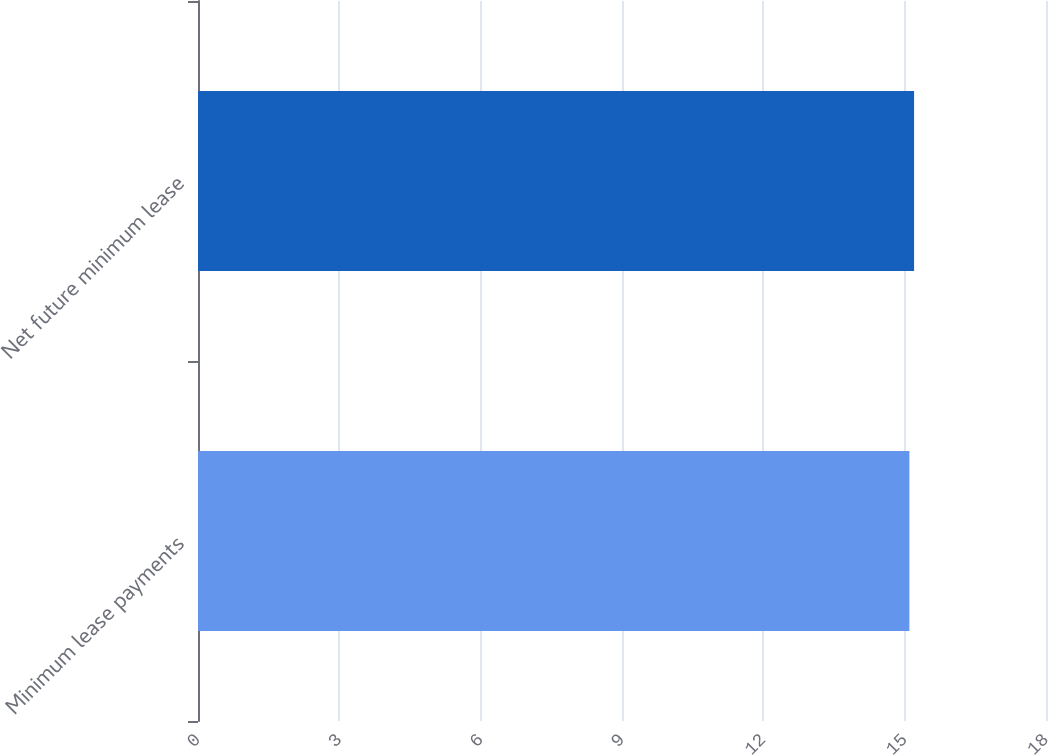Convert chart to OTSL. <chart><loc_0><loc_0><loc_500><loc_500><bar_chart><fcel>Minimum lease payments<fcel>Net future minimum lease<nl><fcel>15.1<fcel>15.2<nl></chart> 